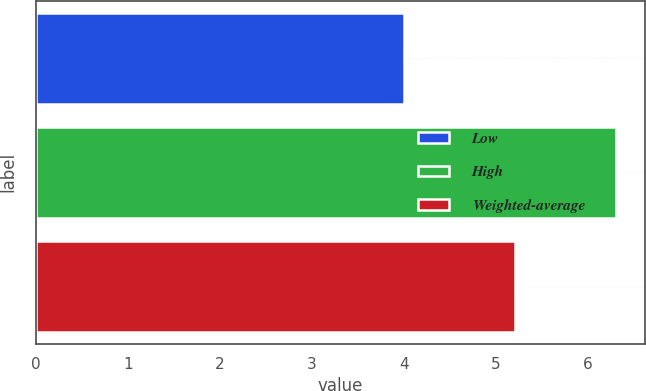<chart> <loc_0><loc_0><loc_500><loc_500><bar_chart><fcel>Low<fcel>High<fcel>Weighted-average<nl><fcel>4<fcel>6.3<fcel>5.2<nl></chart> 